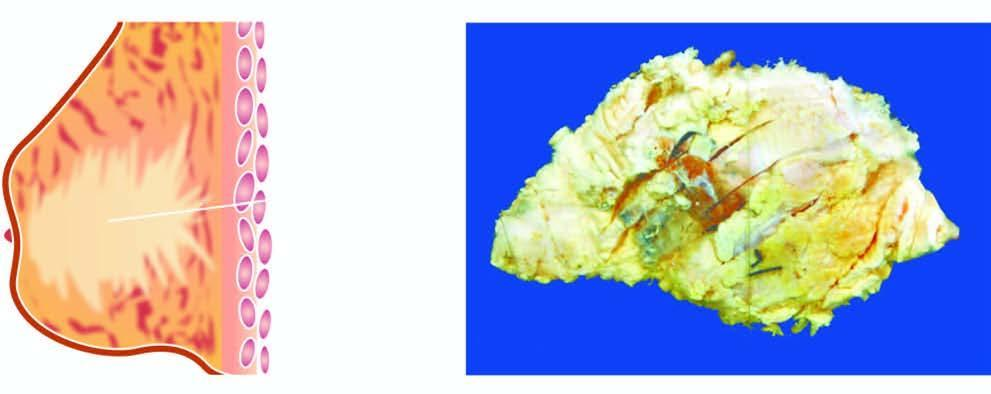what does the breast show?
Answer the question using a single word or phrase. A tumour extending up to nipple and areola 